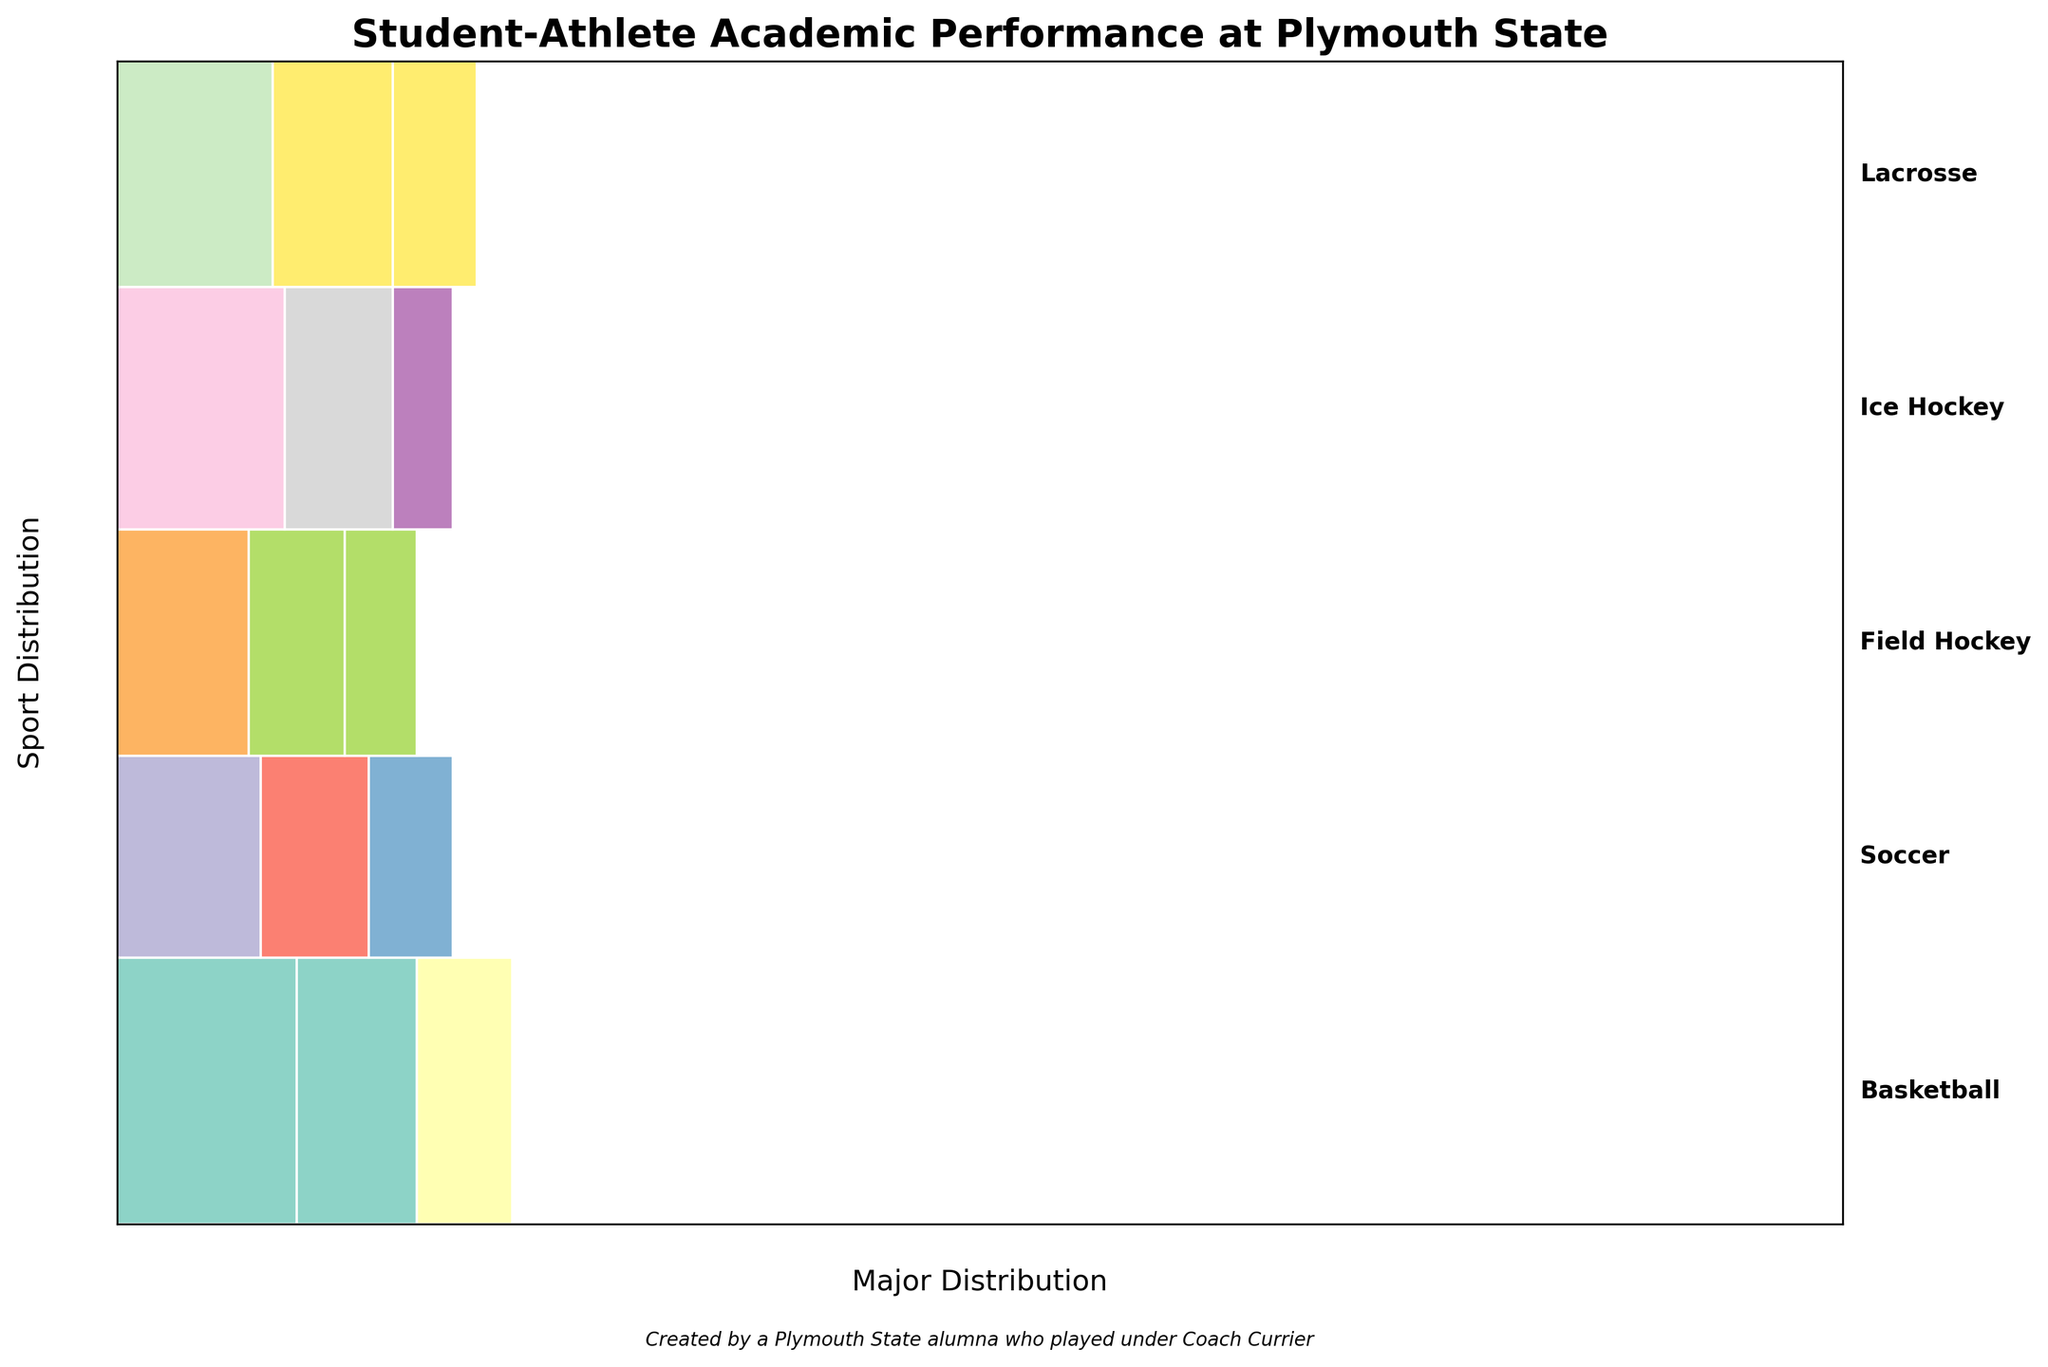What's the title of the plot? The title is usually found at the top of the plot. In this figure, it is directly above the visual elements.
Answer: Student-Athlete Academic Performance at Plymouth State Which sport has the highest count of student-athletes? To determine this, identify the sport segment with the largest vertical section on the plot.
Answer: Basketball How many student-athletes are majoring in Business Administration? Look for the sections labeled "Business Administration" across all sports, and sum their counts. Since only Basketball lists Business Administration, the count is displayed in that section of the mosaic plot.
Answer: 15 Which sport has the smallest segment for Criminal Justice majors? Locate the "Criminal Justice" sections in the plot and compare their sizes. Field Hockey has the only entry with 6 students, which is the smallest segment.
Answer: Field Hockey What is the total count of student-athletes in Ice Hockey? Sum the counts given for Ice Hockey's sections: Sport Management, Marketing, and Computer Science. 14 + 9 + 5 = 28
Answer: 28 Which major is most popular among Lacrosse players? Identify the largest segment within the Lacrosse portion of the mosaic plot. Tour Management has the largest vertical size.
Answer: Tourism Management Compare the count of History majors between Soccer and Ice Hockey. Which sport has more students in this major? Note that neither sport lists "History" as a major, so the count is zero for both.
Answer: Neither (0 in both) What is the total number of student-athletes represented in this plot? Sum all counts presented: 15 + 10 + 8 + 12 + 9 + 7 + 11 + 8 + 6 + 14 + 9 + 5 + 13 + 10 + 7 = 144
Answer: 144 Which major has more students, Nursing or Computer Science? Compare the respective segments for each major. Nursing (11) is larger than Computer Science (5).
Answer: Nursing (11 > 5) 